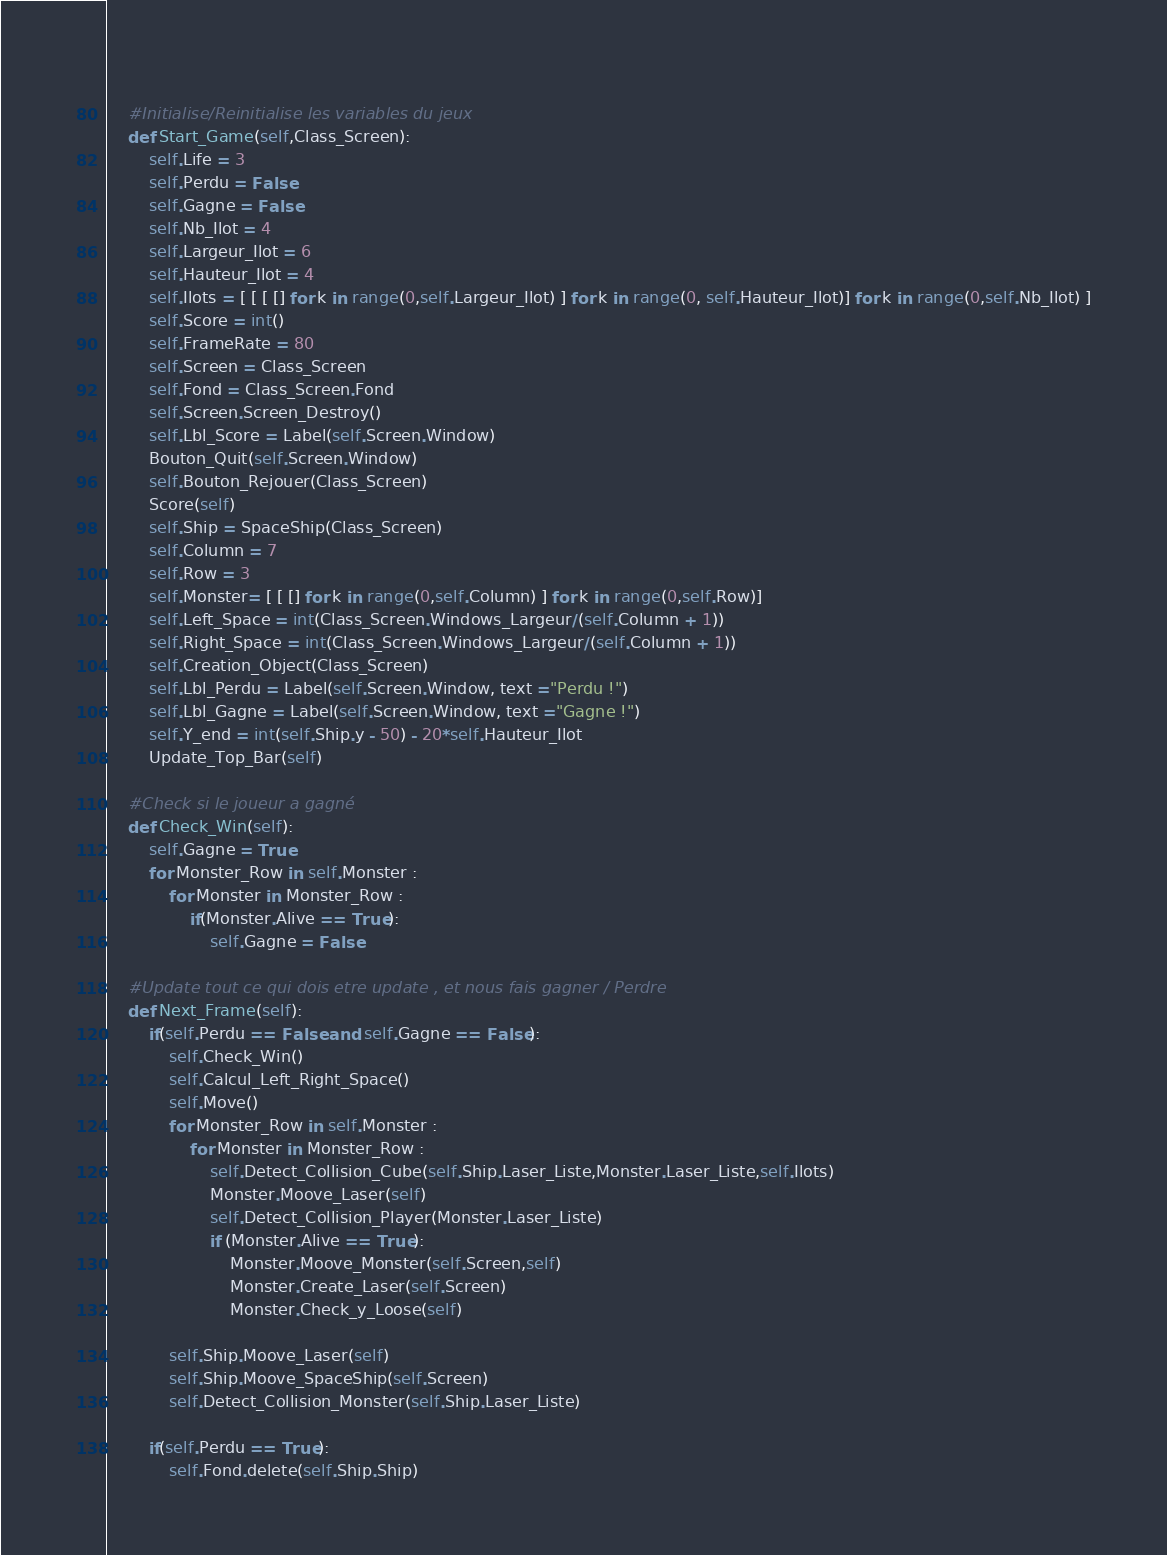Convert code to text. <code><loc_0><loc_0><loc_500><loc_500><_Python_>        
    #Initialise/Reinitialise les variables du jeux
    def Start_Game(self,Class_Screen):
        self.Life = 3
        self.Perdu = False 
        self.Gagne = False
        self.Nb_Ilot = 4 
        self.Largeur_Ilot = 6
        self.Hauteur_Ilot = 4
        self.Ilots = [ [ [ [] for k in range(0,self.Largeur_Ilot) ] for k in range(0, self.Hauteur_Ilot)] for k in range(0,self.Nb_Ilot) ]
        self.Score = int()
        self.FrameRate = 80
        self.Screen = Class_Screen
        self.Fond = Class_Screen.Fond
        self.Screen.Screen_Destroy()
        self.Lbl_Score = Label(self.Screen.Window)
        Bouton_Quit(self.Screen.Window)
        self.Bouton_Rejouer(Class_Screen)
        Score(self)
        self.Ship = SpaceShip(Class_Screen)
        self.Column = 7
        self.Row = 3
        self.Monster= [ [ [] for k in range(0,self.Column) ] for k in range(0,self.Row)]
        self.Left_Space = int(Class_Screen.Windows_Largeur/(self.Column + 1))
        self.Right_Space = int(Class_Screen.Windows_Largeur/(self.Column + 1))
        self.Creation_Object(Class_Screen)
        self.Lbl_Perdu = Label(self.Screen.Window, text ="Perdu !")
        self.Lbl_Gagne = Label(self.Screen.Window, text ="Gagne !")
        self.Y_end = int(self.Ship.y - 50) - 20*self.Hauteur_Ilot
        Update_Top_Bar(self)
    
    #Check si le joueur a gagné
    def Check_Win(self):
        self.Gagne = True
        for Monster_Row in self.Monster : 
            for Monster in Monster_Row :
                if(Monster.Alive == True):
                    self.Gagne = False
        
    #Update tout ce qui dois etre update , et nous fais gagner / Perdre
    def Next_Frame(self):
        if(self.Perdu == False and self.Gagne == False):
            self.Check_Win()
            self.Calcul_Left_Right_Space()
            self.Move()
            for Monster_Row in self.Monster : 
                for Monster in Monster_Row :
                    self.Detect_Collision_Cube(self.Ship.Laser_Liste,Monster.Laser_Liste,self.Ilots)
                    Monster.Moove_Laser(self)
                    self.Detect_Collision_Player(Monster.Laser_Liste)
                    if (Monster.Alive == True):
                        Monster.Moove_Monster(self.Screen,self)
                        Monster.Create_Laser(self.Screen)
                        Monster.Check_y_Loose(self)
            
            self.Ship.Moove_Laser(self)
            self.Ship.Moove_SpaceShip(self.Screen)
            self.Detect_Collision_Monster(self.Ship.Laser_Liste)

        if(self.Perdu == True):
            self.Fond.delete(self.Ship.Ship)</code> 